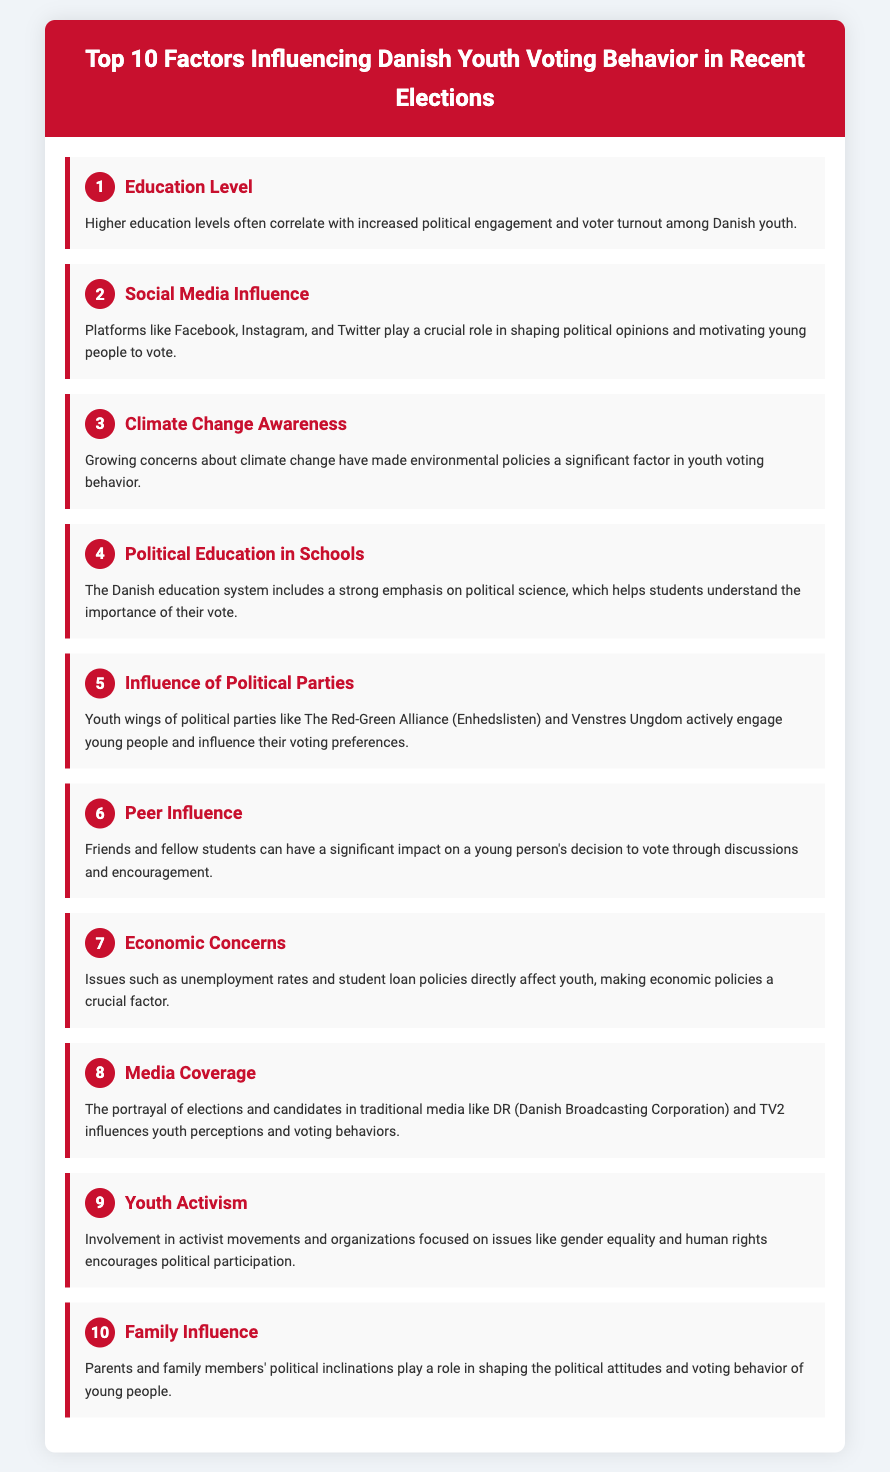what is the top factor influencing Danish youth voting behavior? The document lists "Education Level" as the top factor influencing Danish youth voting behavior.
Answer: Education Level which factor ranks fifth? The fifth factor in the list is "Influence of Political Parties."
Answer: Influence of Political Parties how many factors are listed in the document? The document includes a total of ten factors influencing youth voting behavior.
Answer: 10 what impact do peer interactions have on voting behavior? Peer influence is significant as it affects a young person's decision to vote through discussions and encouragement.
Answer: Significant impact what factor is associated with economic issues among youth? The document mentions "Economic Concerns" as a factor related to unemployment rates and student loan policies.
Answer: Economic Concerns which organization mentioned actively engages young people? The document references the youth wings of political parties, including "The Red-Green Alliance."
Answer: The Red-Green Alliance how does media coverage affect youth perceptions? Media coverage shapes youth perceptions and influences their voting behaviors.
Answer: Shapes perceptions what is the rank of "Climate Change Awareness"? "Climate Change Awareness" is listed as the third factor.
Answer: 3 